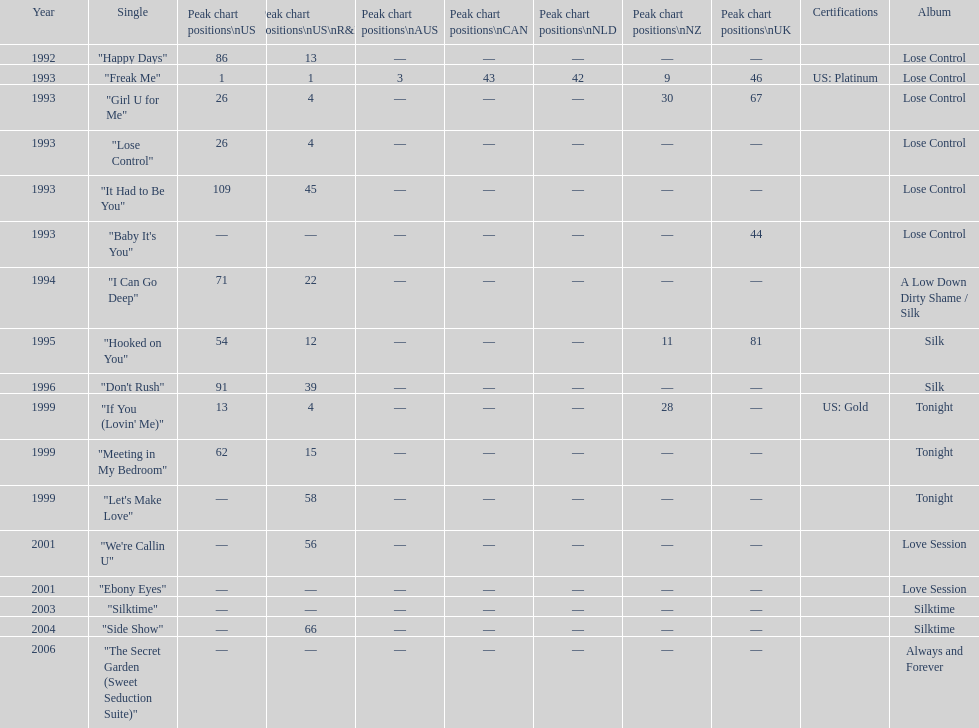Compare "i can go deep" with "don't rush". which was higher on the us and us r&b charts? "I Can Go Deep". 